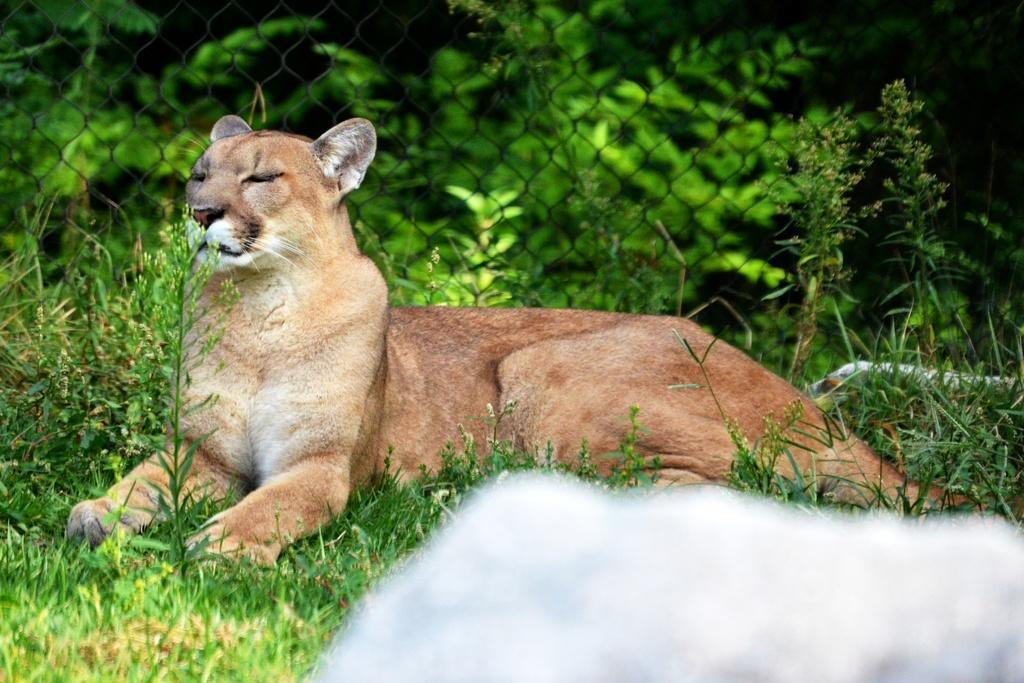What animal is in the image? There is a Cougar in the image. What is the Cougar doing in the image? The Cougar is sitting on the ground. What is the ground covered with? The ground is covered in greenery. What is located beside the Cougar? There is a fence beside the Cougar. What can be seen in the background of the image? There are plants in the background of the image. How many mice are hiding behind the fence in the image? There are no mice visible in the image, and therefore no mice can be hiding behind the fence. What order is the Cougar following in the image? The image does not depict the Cougar following any specific order, as it is a still photograph. 